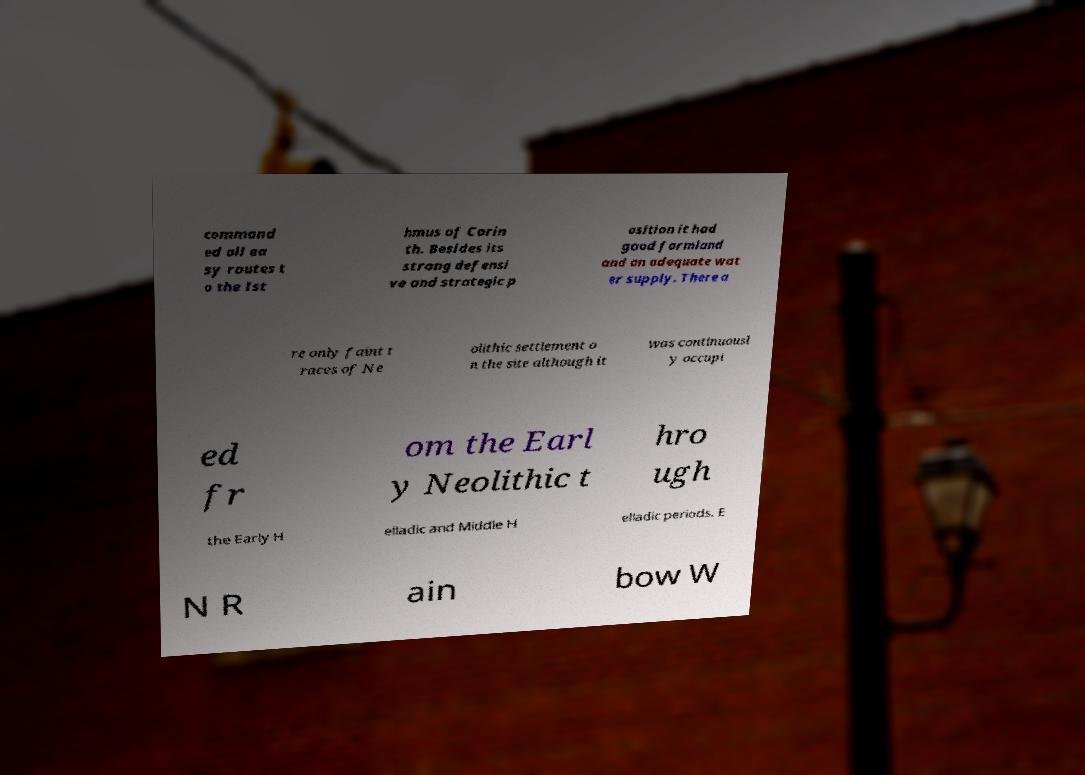Can you accurately transcribe the text from the provided image for me? command ed all ea sy routes t o the Ist hmus of Corin th. Besides its strong defensi ve and strategic p osition it had good farmland and an adequate wat er supply. There a re only faint t races of Ne olithic settlement o n the site although it was continuousl y occupi ed fr om the Earl y Neolithic t hro ugh the Early H elladic and Middle H elladic periods. E N R ain bow W 